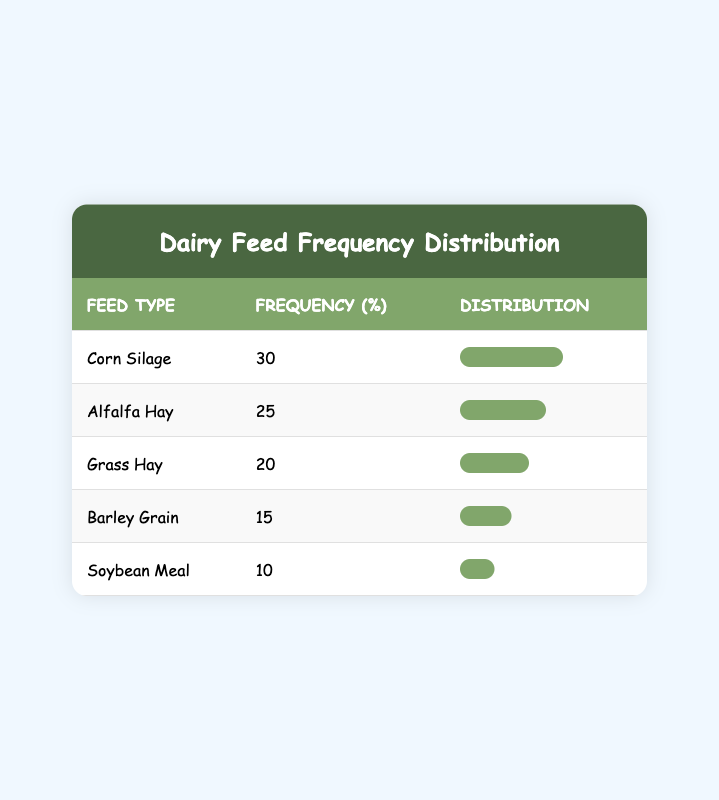What is the frequency of Corn Silage? The table lists Corn Silage with a frequency of 30%.
Answer: 30% Which feed type has the lowest frequency? The feed type with the lowest frequency in the table is Soybean Meal, with a frequency of 10%.
Answer: Soybean Meal What is the frequency percentage of Barley Grain? The table indicates that Barley Grain has a frequency of 15%.
Answer: 15% What is the total frequency of all feed types? To find the total frequency, we sum the individual frequencies: 25 + 30 + 20 + 15 + 10 = 100%.
Answer: 100% Is the frequency of Grass Hay greater than that of Alfalfa Hay? Grass Hay has a frequency of 20% while Alfalfa Hay has 25%, thus Grass Hay's frequency is not greater.
Answer: No Which two feed types combined have a frequency of more than 50%? By adding Alfalfa Hay (25%) and Corn Silage (30%), we reach 55%, which is more than 50%. Additionally, Corn Silage (30%) and Grass Hay (20%) total 50%, which is not more than 50%.
Answer: Alfalfa Hay and Corn Silage What is the average frequency of the feed types listed? To calculate the average frequency, we take the total frequency (100%) and divide by the number of feed types (5): 100/5 = 20%.
Answer: 20% How many more percentages does Corn Silage have than Soybean Meal? Corn Silage at 30% has 20% more than Soybean Meal which has 10% (30 - 10 = 20).
Answer: 20% Which feed type accounts for more than 20% of total frequency? Corn Silage at 30%, Alfalfa Hay at 25%, and Grass Hay at 20% account for either more than or equal to 20%.
Answer: Corn Silage and Alfalfa Hay 